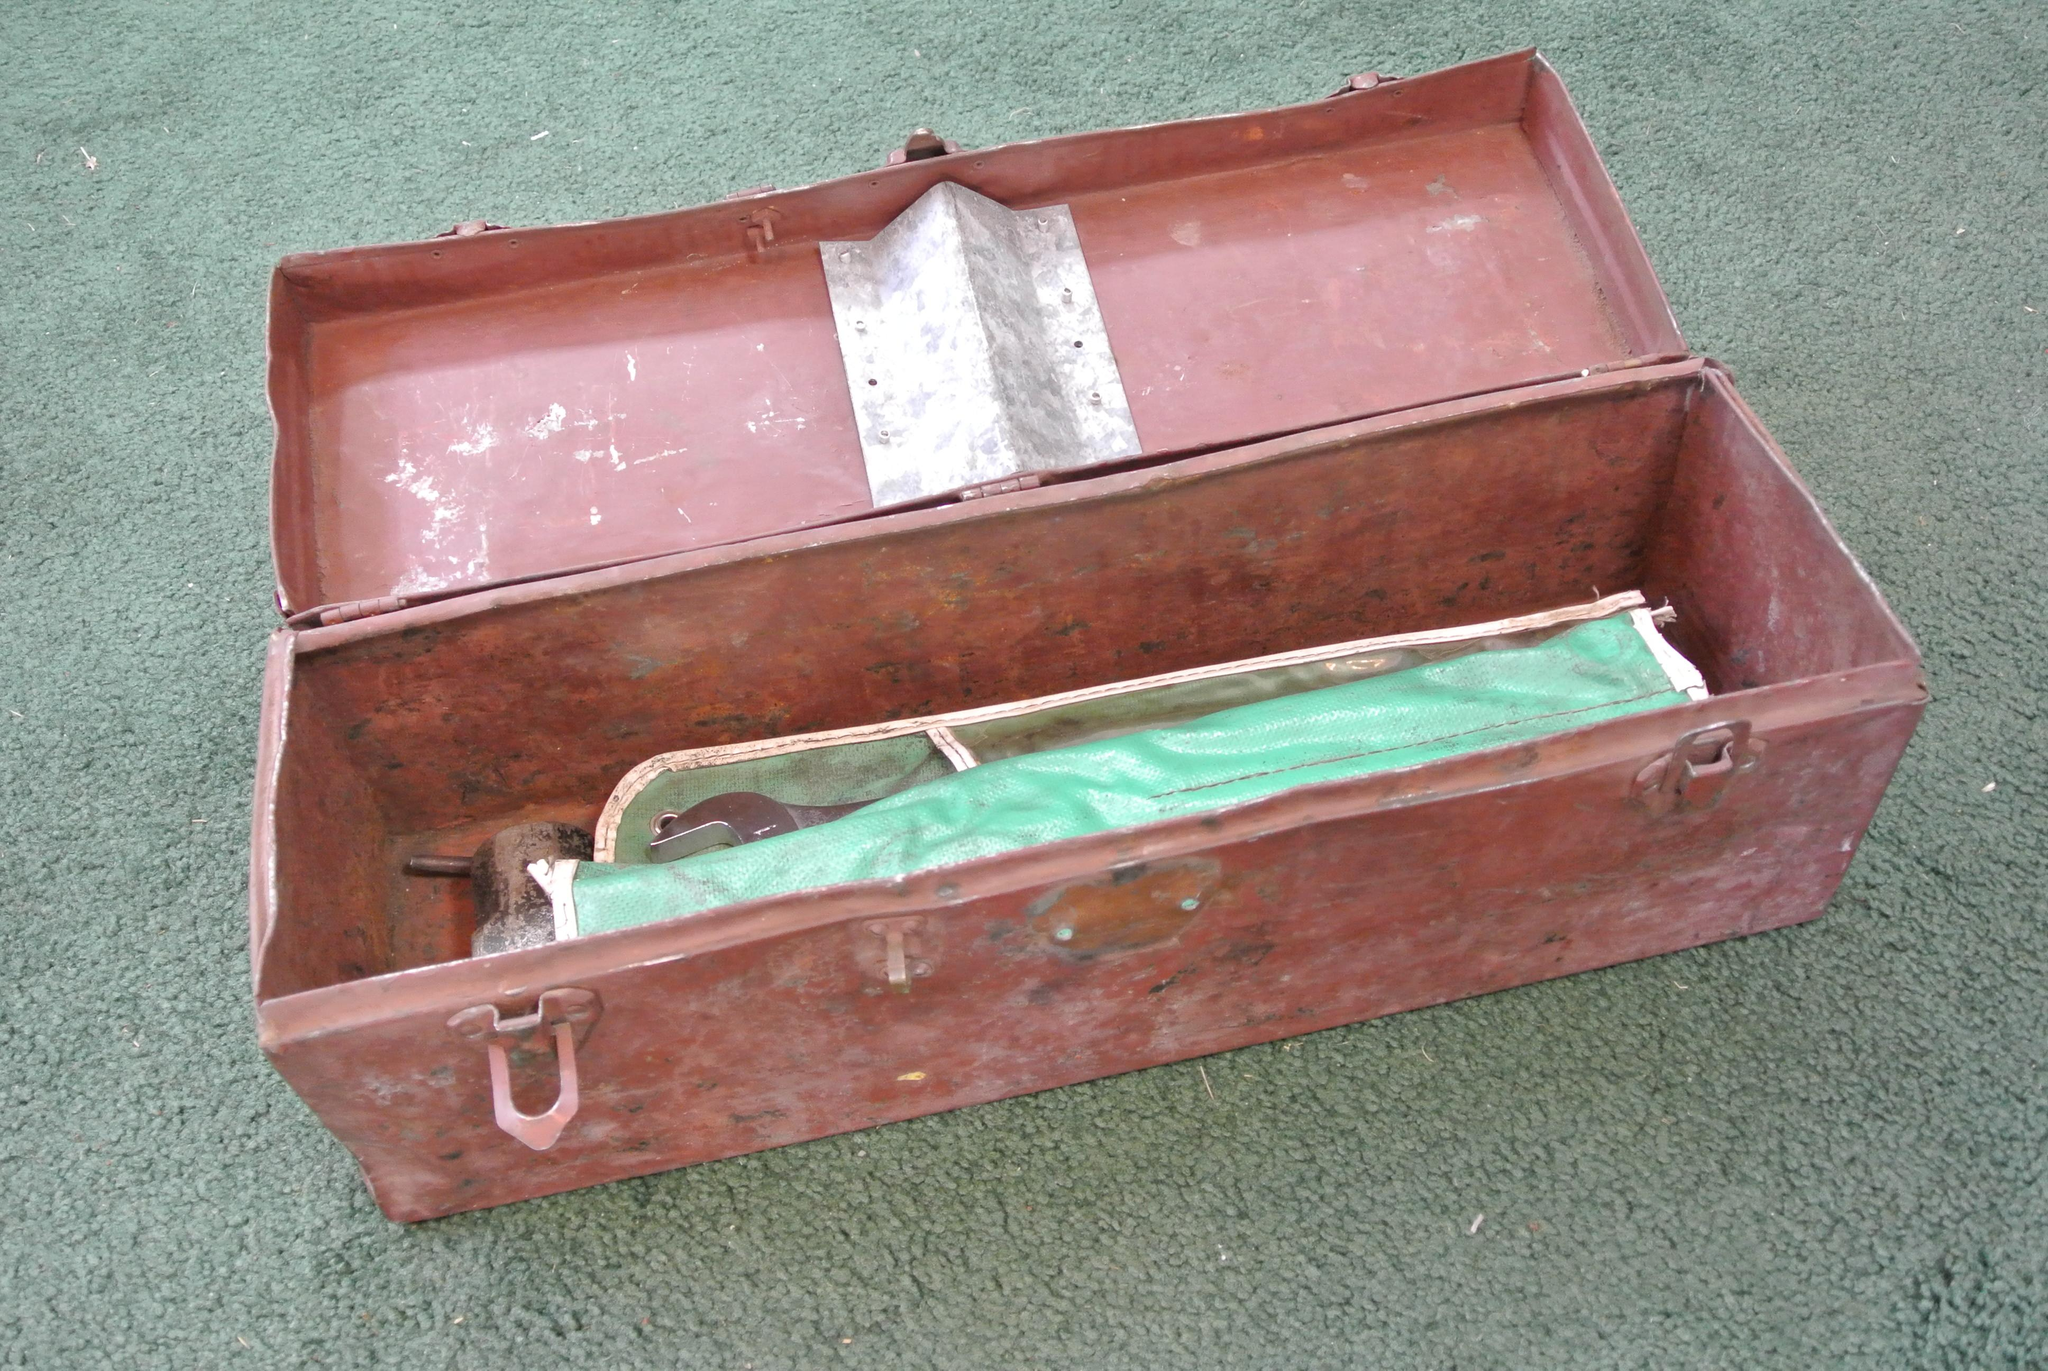What is located on the floor in the image? There is a box on the floor in the image. Can you describe the contents of the box? There is an object placed inside the box. How many friends are playing in the alley behind the box? There is no mention of an alley or friends playing in the image. The image only describes a box on the floor with an object inside. 